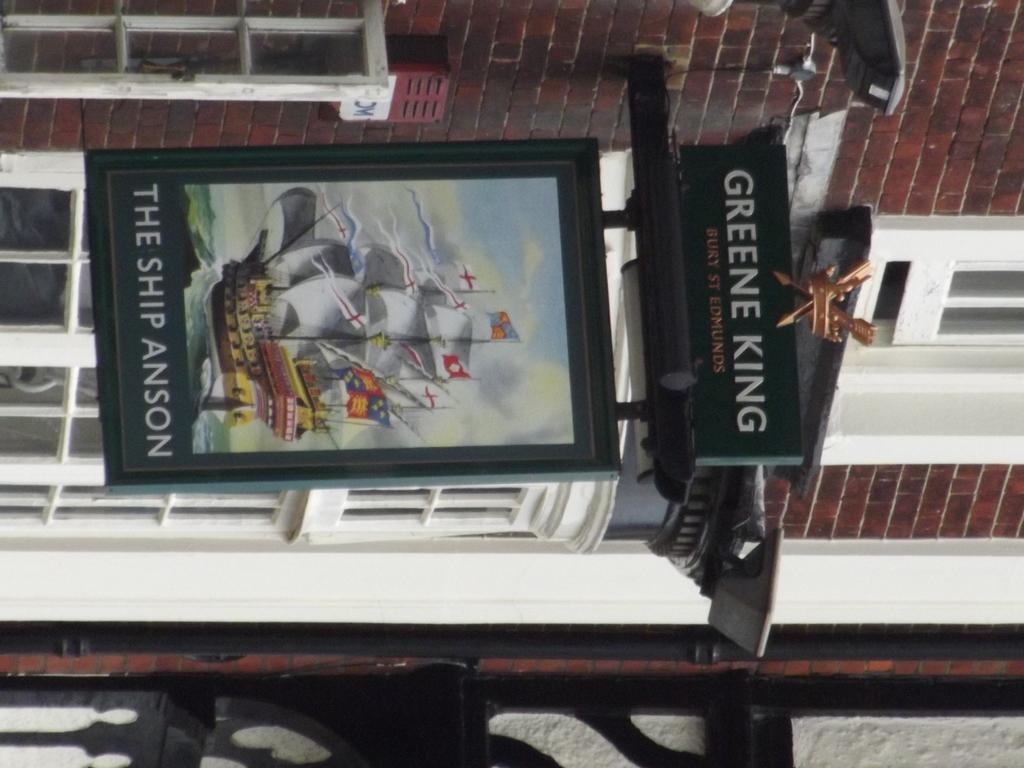Provide a one-sentence caption for the provided image. A green poster containing the white text 'The Ship Anson'. 